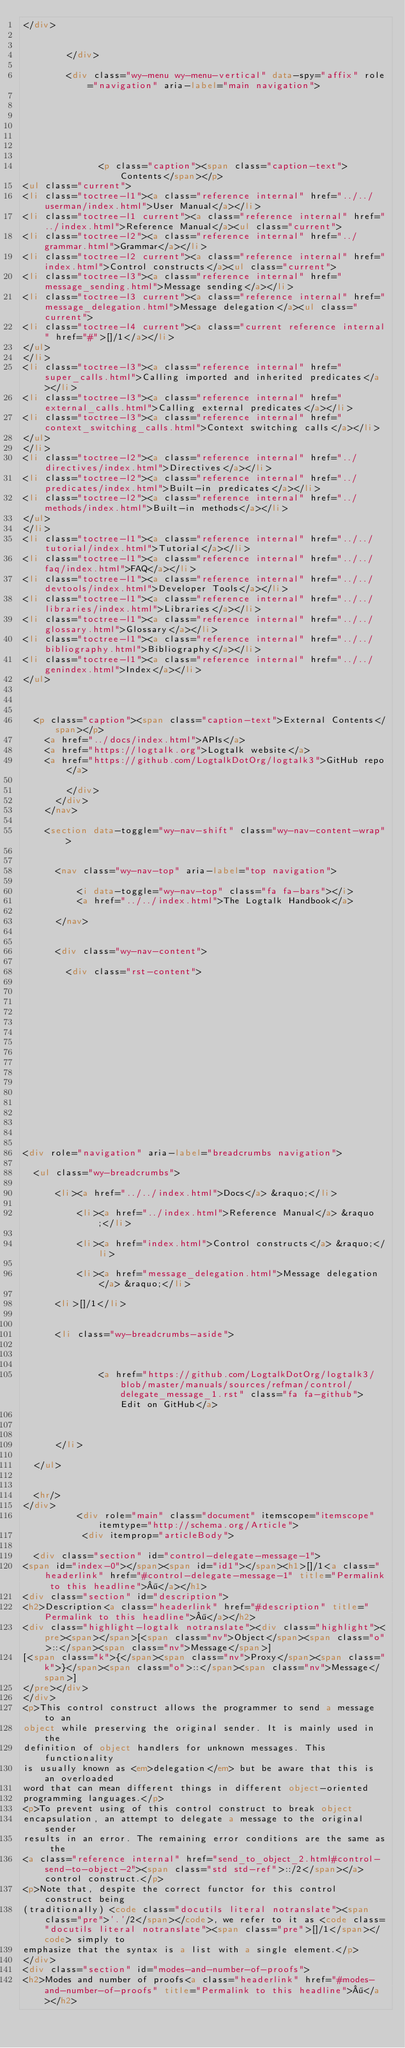<code> <loc_0><loc_0><loc_500><loc_500><_HTML_></div>

          
        </div>

        <div class="wy-menu wy-menu-vertical" data-spy="affix" role="navigation" aria-label="main navigation">
          
    
            
            
              
            
            
              <p class="caption"><span class="caption-text">Contents</span></p>
<ul class="current">
<li class="toctree-l1"><a class="reference internal" href="../../userman/index.html">User Manual</a></li>
<li class="toctree-l1 current"><a class="reference internal" href="../index.html">Reference Manual</a><ul class="current">
<li class="toctree-l2"><a class="reference internal" href="../grammar.html">Grammar</a></li>
<li class="toctree-l2 current"><a class="reference internal" href="index.html">Control constructs</a><ul class="current">
<li class="toctree-l3"><a class="reference internal" href="message_sending.html">Message sending</a></li>
<li class="toctree-l3 current"><a class="reference internal" href="message_delegation.html">Message delegation</a><ul class="current">
<li class="toctree-l4 current"><a class="current reference internal" href="#">[]/1</a></li>
</ul>
</li>
<li class="toctree-l3"><a class="reference internal" href="super_calls.html">Calling imported and inherited predicates</a></li>
<li class="toctree-l3"><a class="reference internal" href="external_calls.html">Calling external predicates</a></li>
<li class="toctree-l3"><a class="reference internal" href="context_switching_calls.html">Context switching calls</a></li>
</ul>
</li>
<li class="toctree-l2"><a class="reference internal" href="../directives/index.html">Directives</a></li>
<li class="toctree-l2"><a class="reference internal" href="../predicates/index.html">Built-in predicates</a></li>
<li class="toctree-l2"><a class="reference internal" href="../methods/index.html">Built-in methods</a></li>
</ul>
</li>
<li class="toctree-l1"><a class="reference internal" href="../../tutorial/index.html">Tutorial</a></li>
<li class="toctree-l1"><a class="reference internal" href="../../faq/index.html">FAQ</a></li>
<li class="toctree-l1"><a class="reference internal" href="../../devtools/index.html">Developer Tools</a></li>
<li class="toctree-l1"><a class="reference internal" href="../../libraries/index.html">Libraries</a></li>
<li class="toctree-l1"><a class="reference internal" href="../../glossary.html">Glossary</a></li>
<li class="toctree-l1"><a class="reference internal" href="../../bibliography.html">Bibliography</a></li>
<li class="toctree-l1"><a class="reference internal" href="../../genindex.html">Index</a></li>
</ul>

            
          
	<p class="caption"><span class="caption-text">External Contents</span></p>
    <a href="../docs/index.html">APIs</a>
    <a href="https://logtalk.org">Logtalk website</a>
    <a href="https://github.com/LogtalkDotOrg/logtalk3">GitHub repo</a>
  
        </div>
      </div>
    </nav>

    <section data-toggle="wy-nav-shift" class="wy-nav-content-wrap">

      
      <nav class="wy-nav-top" aria-label="top navigation">
        
          <i data-toggle="wy-nav-top" class="fa fa-bars"></i>
          <a href="../../index.html">The Logtalk Handbook</a>
        
      </nav>


      <div class="wy-nav-content">
        
        <div class="rst-content">
        
          















<div role="navigation" aria-label="breadcrumbs navigation">

  <ul class="wy-breadcrumbs">
    
      <li><a href="../../index.html">Docs</a> &raquo;</li>
        
          <li><a href="../index.html">Reference Manual</a> &raquo;</li>
        
          <li><a href="index.html">Control constructs</a> &raquo;</li>
        
          <li><a href="message_delegation.html">Message delegation</a> &raquo;</li>
        
      <li>[]/1</li>
    
    
      <li class="wy-breadcrumbs-aside">
        
            
            
              <a href="https://github.com/LogtalkDotOrg/logtalk3/blob/master/manuals/sources/refman/control/delegate_message_1.rst" class="fa fa-github"> Edit on GitHub</a>
            
          
        
      </li>
    
  </ul>

  
  <hr/>
</div>
          <div role="main" class="document" itemscope="itemscope" itemtype="http://schema.org/Article">
           <div itemprop="articleBody">
            
  <div class="section" id="control-delegate-message-1">
<span id="index-0"></span><span id="id1"></span><h1>[]/1<a class="headerlink" href="#control-delegate-message-1" title="Permalink to this headline">¶</a></h1>
<div class="section" id="description">
<h2>Description<a class="headerlink" href="#description" title="Permalink to this headline">¶</a></h2>
<div class="highlight-logtalk notranslate"><div class="highlight"><pre><span></span>[<span class="nv">Object</span><span class="o">::</span><span class="nv">Message</span>]
[<span class="k">{</span><span class="nv">Proxy</span><span class="k">}</span><span class="o">::</span><span class="nv">Message</span>]
</pre></div>
</div>
<p>This control construct allows the programmer to send a message to an
object while preserving the original sender. It is mainly used in the
definition of object handlers for unknown messages. This functionality
is usually known as <em>delegation</em> but be aware that this is an overloaded
word that can mean different things in different object-oriented
programming languages.</p>
<p>To prevent using of this control construct to break object
encapsulation, an attempt to delegate a message to the original sender
results in an error. The remaining error conditions are the same as the
<a class="reference internal" href="send_to_object_2.html#control-send-to-object-2"><span class="std std-ref">::/2</span></a> control construct.</p>
<p>Note that, despite the correct functor for this control construct being
(traditionally) <code class="docutils literal notranslate"><span class="pre">'.'/2</span></code>, we refer to it as <code class="docutils literal notranslate"><span class="pre">[]/1</span></code> simply to
emphasize that the syntax is a list with a single element.</p>
</div>
<div class="section" id="modes-and-number-of-proofs">
<h2>Modes and number of proofs<a class="headerlink" href="#modes-and-number-of-proofs" title="Permalink to this headline">¶</a></h2></code> 